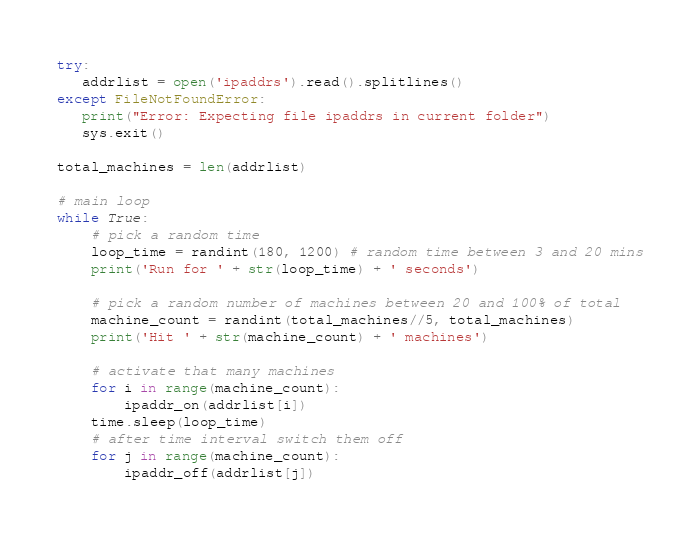<code> <loc_0><loc_0><loc_500><loc_500><_Python_>try:
   addrlist = open('ipaddrs').read().splitlines()
except FileNotFoundError:
   print("Error: Expecting file ipaddrs in current folder")
   sys.exit()

total_machines = len(addrlist)

# main loop
while True:
    # pick a random time
    loop_time = randint(180, 1200) # random time between 3 and 20 mins
    print('Run for ' + str(loop_time) + ' seconds')
  
    # pick a random number of machines between 20 and 100% of total
    machine_count = randint(total_machines//5, total_machines)
    print('Hit ' + str(machine_count) + ' machines')

    # activate that many machines
    for i in range(machine_count):
        ipaddr_on(addrlist[i])
    time.sleep(loop_time)
    # after time interval switch them off 
    for j in range(machine_count):
        ipaddr_off(addrlist[j])
 </code> 